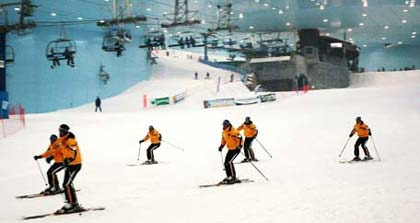Are all the skiers wearing the sharegpt4v/same colored outfit? Yes, all the skiers appear to be wearing uniforms of the sharegpt4v/same color, which seems to be a bright shade of orange. This uniform color could be for group identification or safety reasons. 